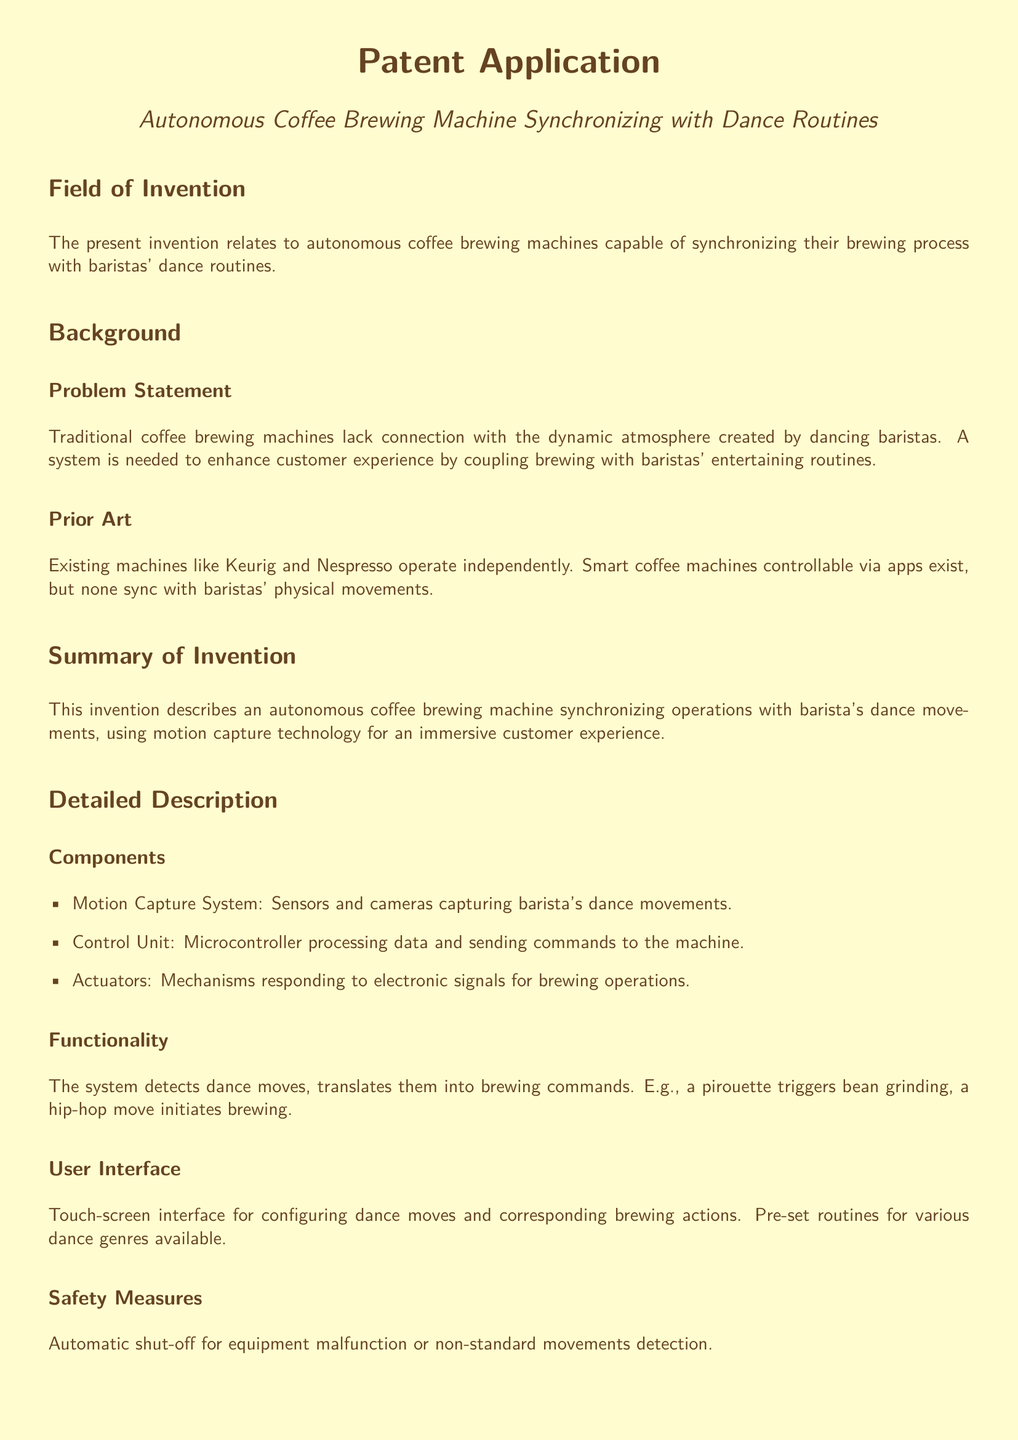What is the invention about? The invention relates to autonomous coffee brewing machines capable of synchronizing their brewing process with baristas' dance routines.
Answer: Synchronizing with dance routines What technology does the machine use? The machine uses motion capture technology to synchronize brewing with dance movements of the barista.
Answer: Motion capture technology What triggers the bean grinding? A pirouette dance move triggers the bean grinding process in the machine.
Answer: A pirouette What is the role of the Control Unit? The Control Unit processes data from the motion capture system and sends commands to the machine for brewing operations.
Answer: Processes data What are the applications of the invention? The invention is applicable in coffee shops, restaurants, and events where synchronized preparation services enhance entertainment.
Answer: Coffee shops What is one advantage of this invention? One advantage is enhanced customer engagement and enjoyment during the coffee brewing process.
Answer: Enhanced customer engagement What safety measure is included in the design? An automatic shut-off feature is included to address equipment malfunction or non-standard movements detection.
Answer: Automatic shut-off What does the User Interface consist of? The User Interface consists of a touch-screen interface for configuring dance moves and corresponding brewing actions.
Answer: Touch-screen interface How does the system respond to dance moves? The system detects dance moves and translates them into brewing commands through colorful and effective synchronization.
Answer: Translates them into brewing commands 